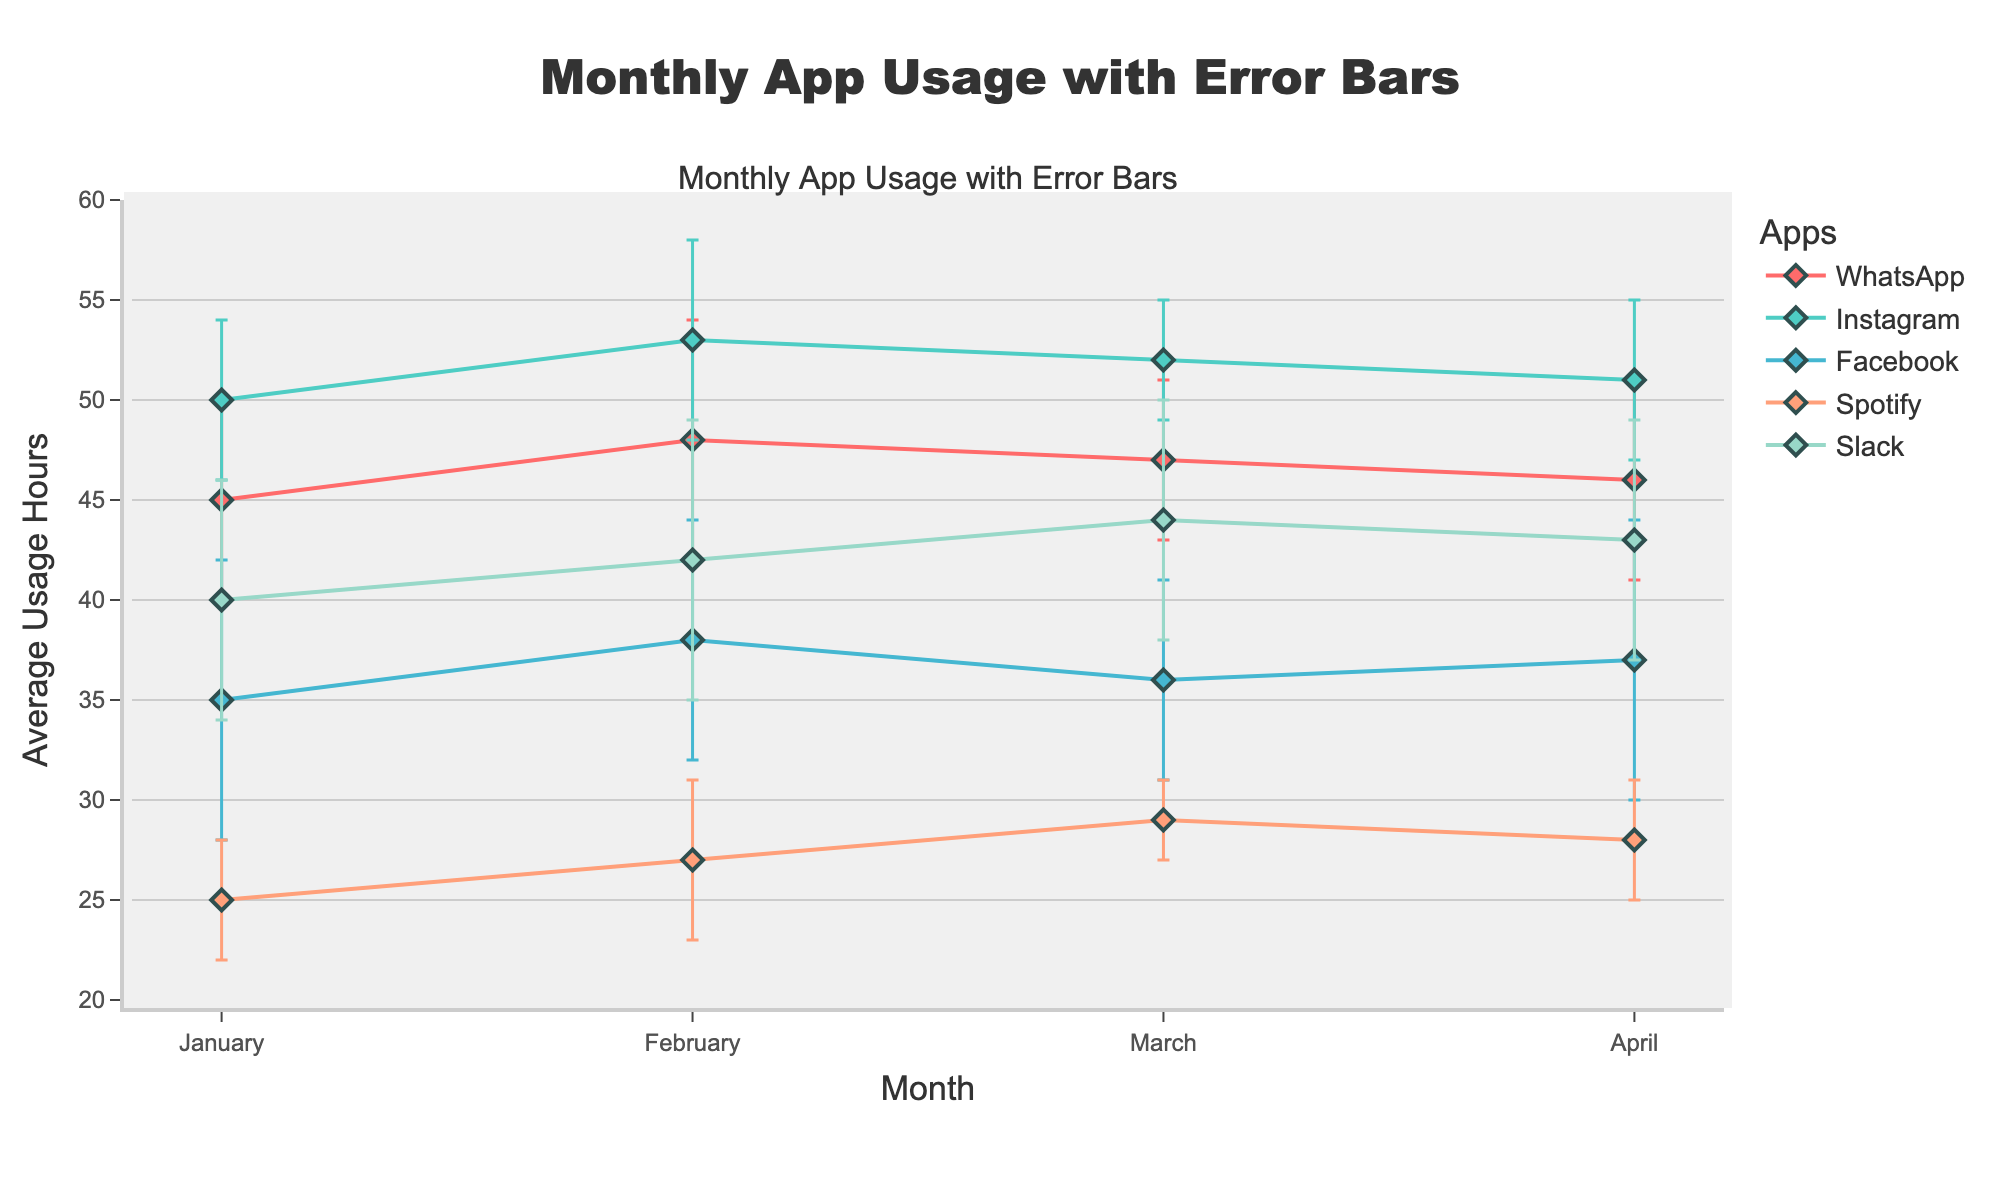What is the title of the plot? The title of the plot can be found at the top of the figure. It reads "Monthly App Usage with Error Bars," indicating the subject of the plot.
Answer: Monthly App Usage with Error Bars How many apps are represented in the plot? By counting the distinct legend entries, we can see that there are five apps represented in the plot.
Answer: Five Which app has the highest average usage hours in January? By looking at the markers for January and comparing the average usage hours (on the y-axis), Instagram has the highest value.
Answer: Instagram Which app has the smallest standard deviation in March? Reviewing the error bars heights for March and comparing their lengths, Spotify has the smallest standard deviation.
Answer: Spotify What is the average of average usage hours for Facebook across all months? The average usage hours for Facebook in each month are 35, 38, 36, and 37. Adding these values gives 146. Dividing by the number of months (4) results in an average (146/4).
Answer: 36.5 Which app showed the most consistent usage with the smallest average standard deviation across all months? By comparing the lengths of error bars (standard deviations) for each app across months, Instagram shows the smallest average standard deviation.
Answer: Instagram In April, which app had a higher average usage hours: WhatsApp or Slack? Comparing WhatsApp and Slack's average usage hours for April on the y-axis, Slack has a higher figure.
Answer: Slack Comparing January and February, which app had the largest increase in average usage hours? Checking the data points for each app between January and February, WhatsApp had an increase from 45 to 48, Instagram from 50 to 53, Facebook from 35 to 38, Spotify from 25 to 27, and Slack from 40 to 42. Instagram had the largest increase of 3 hours.
Answer: Instagram What is the range of average usage hours for WhatsApp across all months? The range can be found by subtracting the smallest value from the largest value for WhatsApp: (48 - 45) = 3.
Answer: 3 Which app experienced the highest user deviation (standard deviation) in any single month? By reviewing the length of error bars, the highest standard deviation is for Slack in February with a length of 7.
Answer: Slack in February 